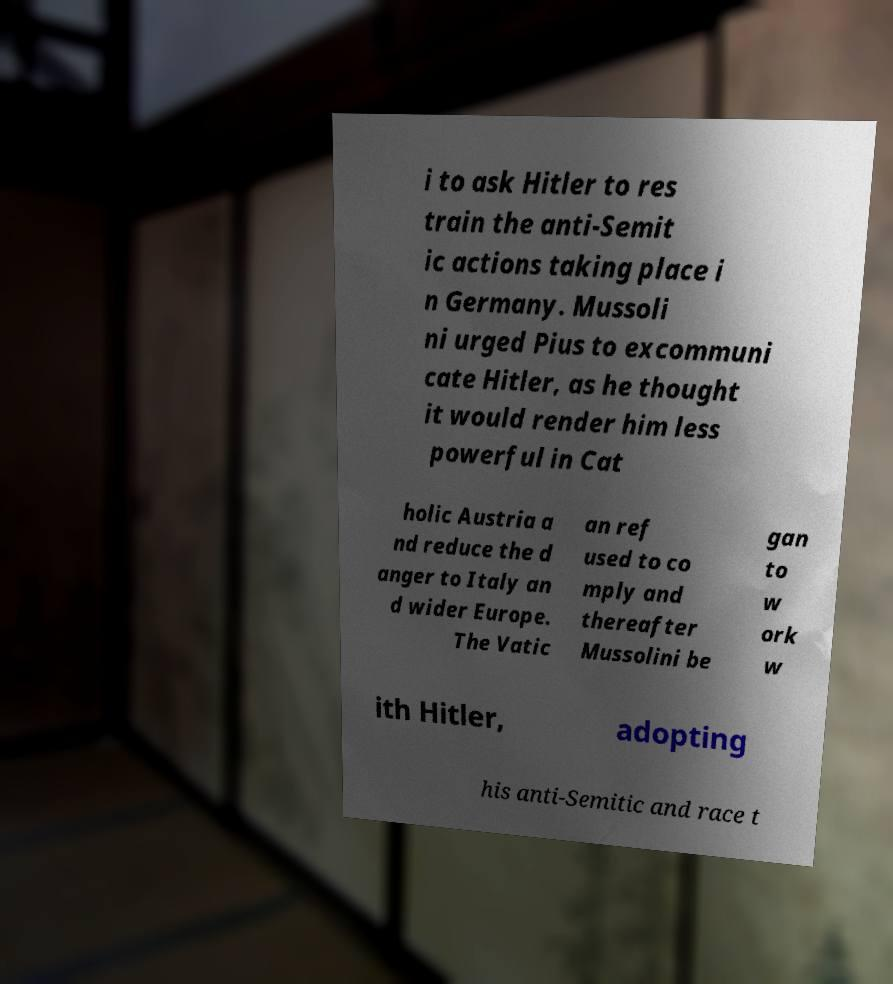Can you accurately transcribe the text from the provided image for me? i to ask Hitler to res train the anti-Semit ic actions taking place i n Germany. Mussoli ni urged Pius to excommuni cate Hitler, as he thought it would render him less powerful in Cat holic Austria a nd reduce the d anger to Italy an d wider Europe. The Vatic an ref used to co mply and thereafter Mussolini be gan to w ork w ith Hitler, adopting his anti-Semitic and race t 